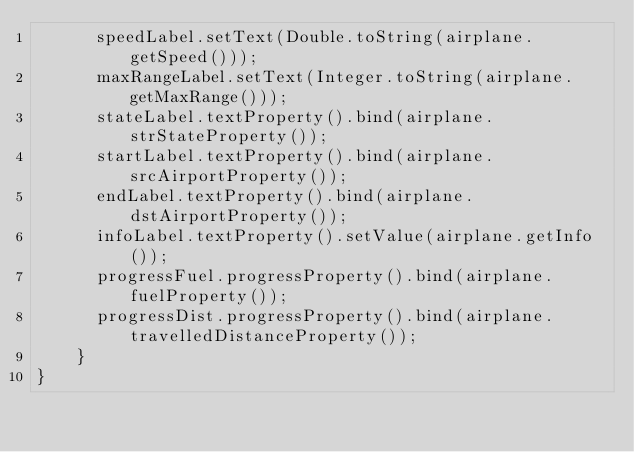Convert code to text. <code><loc_0><loc_0><loc_500><loc_500><_Java_>    	speedLabel.setText(Double.toString(airplane.getSpeed()));
    	maxRangeLabel.setText(Integer.toString(airplane.getMaxRange()));
    	stateLabel.textProperty().bind(airplane.strStateProperty());
    	startLabel.textProperty().bind(airplane.srcAirportProperty());
    	endLabel.textProperty().bind(airplane.dstAirportProperty());
    	infoLabel.textProperty().setValue(airplane.getInfo());
    	progressFuel.progressProperty().bind(airplane.fuelProperty());
    	progressDist.progressProperty().bind(airplane.travelledDistanceProperty());
    }
}
</code> 